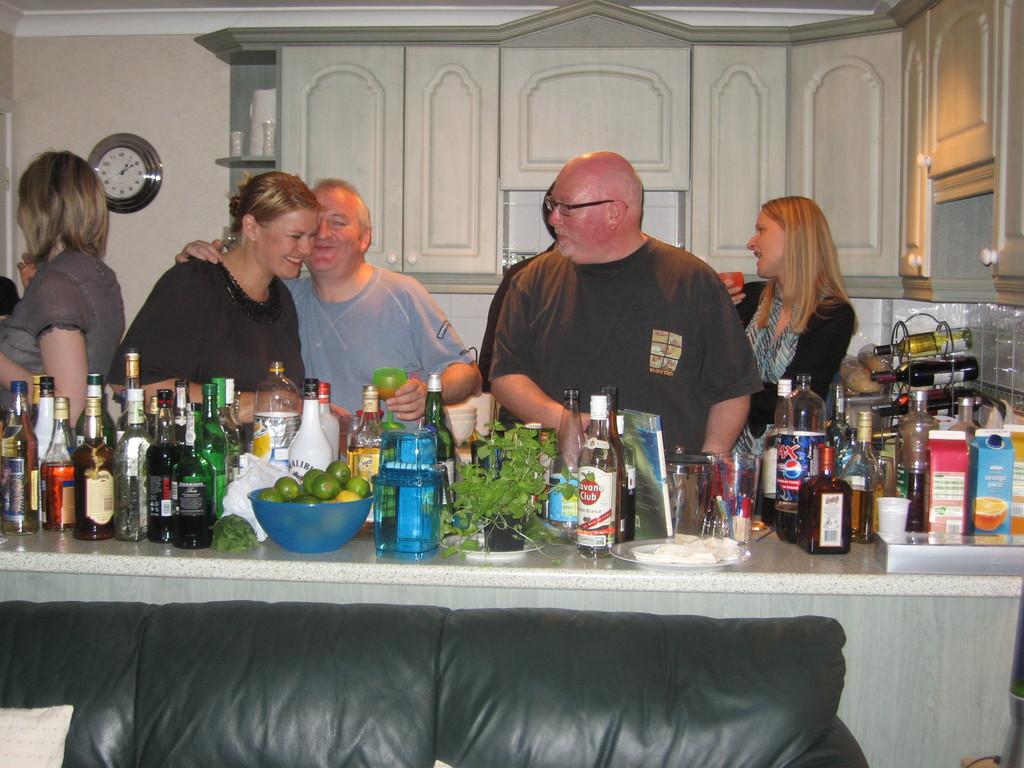What time does the clock read on the wall?
Your answer should be compact. 1:10. What is the name of the rum in the white bottle behind the limes?
Your response must be concise. Malibu. 